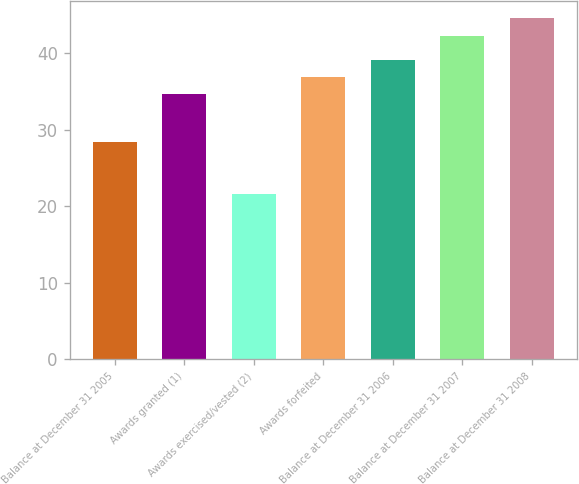Convert chart to OTSL. <chart><loc_0><loc_0><loc_500><loc_500><bar_chart><fcel>Balance at December 31 2005<fcel>Awards granted (1)<fcel>Awards exercised/vested (2)<fcel>Awards forfeited<fcel>Balance at December 31 2006<fcel>Balance at December 31 2007<fcel>Balance at December 31 2008<nl><fcel>28.42<fcel>34.65<fcel>21.63<fcel>36.9<fcel>39.15<fcel>42.3<fcel>44.55<nl></chart> 